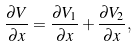Convert formula to latex. <formula><loc_0><loc_0><loc_500><loc_500>\frac { \partial V } { \partial x } = \frac { \partial V _ { 1 } } { \partial x } + \frac { \partial V _ { 2 } } { \partial x } ,</formula> 